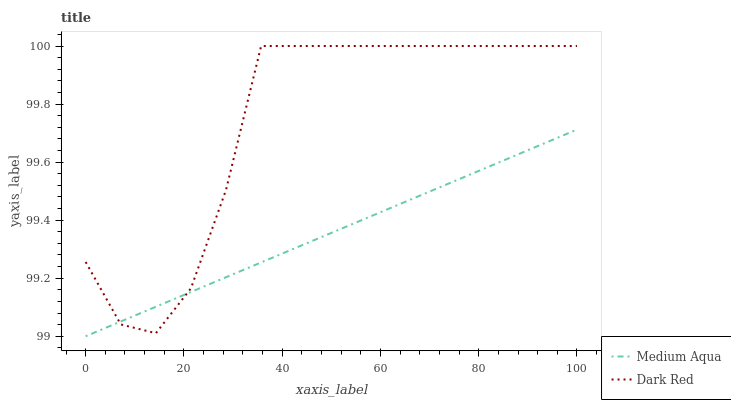Does Medium Aqua have the minimum area under the curve?
Answer yes or no. Yes. Does Dark Red have the maximum area under the curve?
Answer yes or no. Yes. Does Medium Aqua have the maximum area under the curve?
Answer yes or no. No. Is Medium Aqua the smoothest?
Answer yes or no. Yes. Is Dark Red the roughest?
Answer yes or no. Yes. Is Medium Aqua the roughest?
Answer yes or no. No. Does Dark Red have the highest value?
Answer yes or no. Yes. Does Medium Aqua have the highest value?
Answer yes or no. No. Does Dark Red intersect Medium Aqua?
Answer yes or no. Yes. Is Dark Red less than Medium Aqua?
Answer yes or no. No. Is Dark Red greater than Medium Aqua?
Answer yes or no. No. 